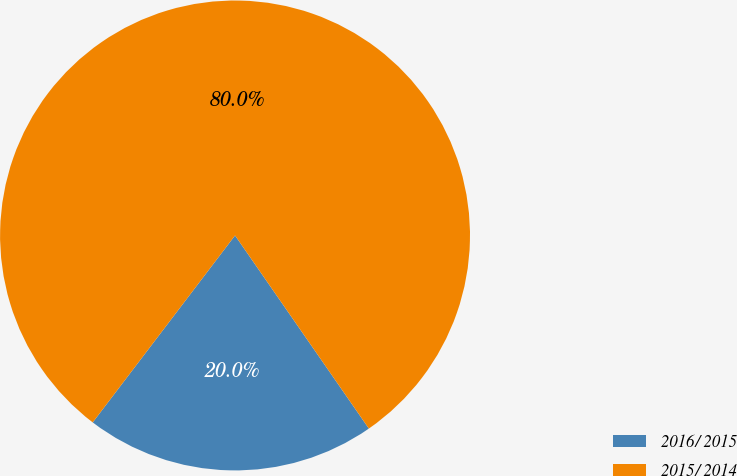Convert chart. <chart><loc_0><loc_0><loc_500><loc_500><pie_chart><fcel>2016/ 2015<fcel>2015/ 2014<nl><fcel>20.0%<fcel>80.0%<nl></chart> 